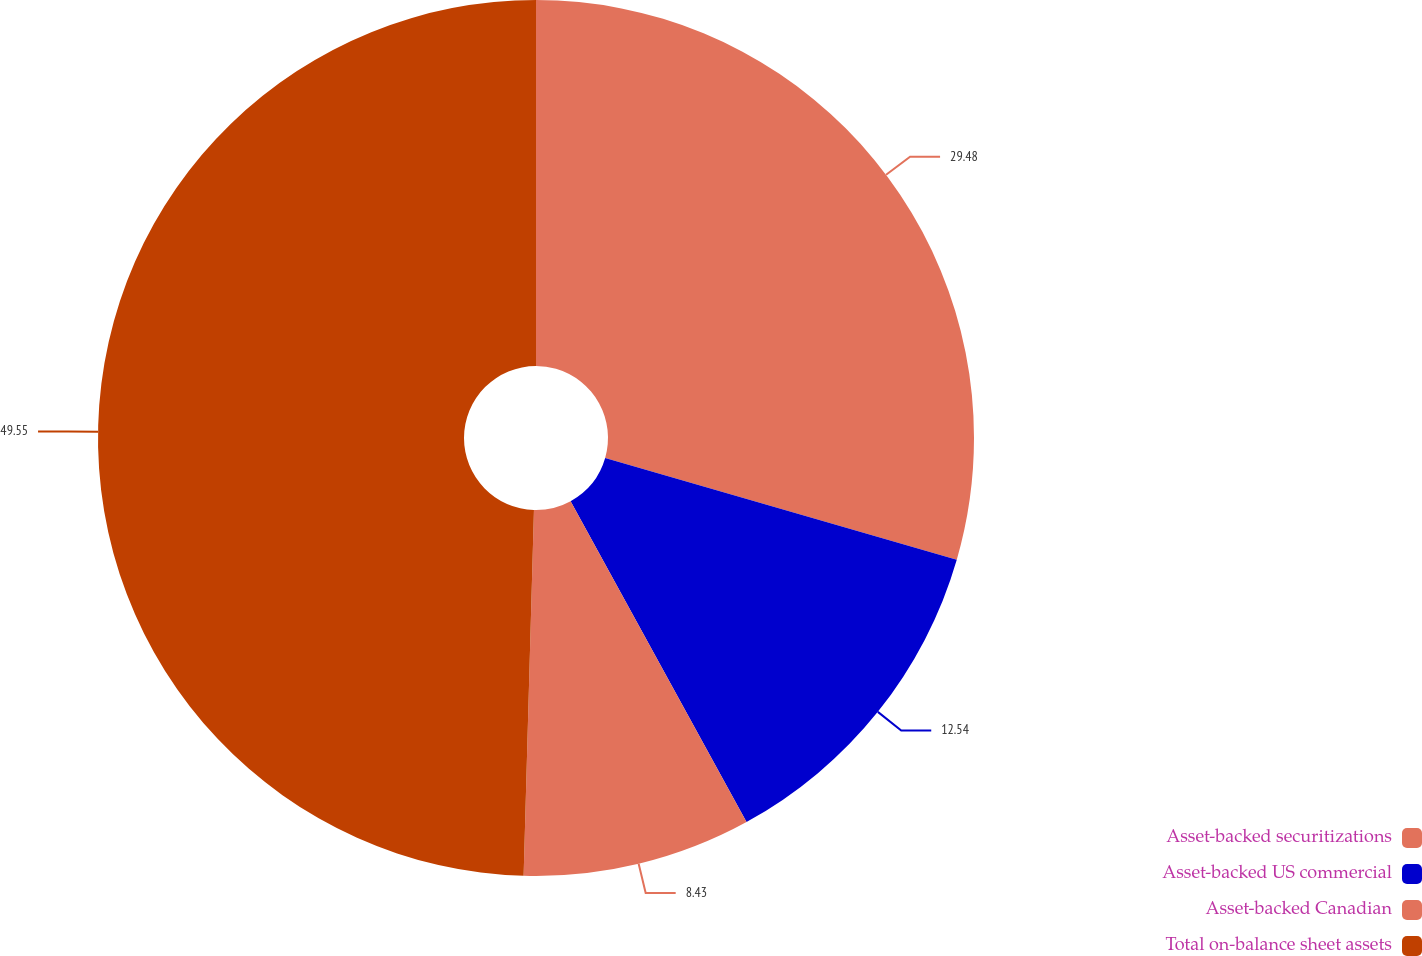Convert chart. <chart><loc_0><loc_0><loc_500><loc_500><pie_chart><fcel>Asset-backed securitizations<fcel>Asset-backed US commercial<fcel>Asset-backed Canadian<fcel>Total on-balance sheet assets<nl><fcel>29.48%<fcel>12.54%<fcel>8.43%<fcel>49.55%<nl></chart> 